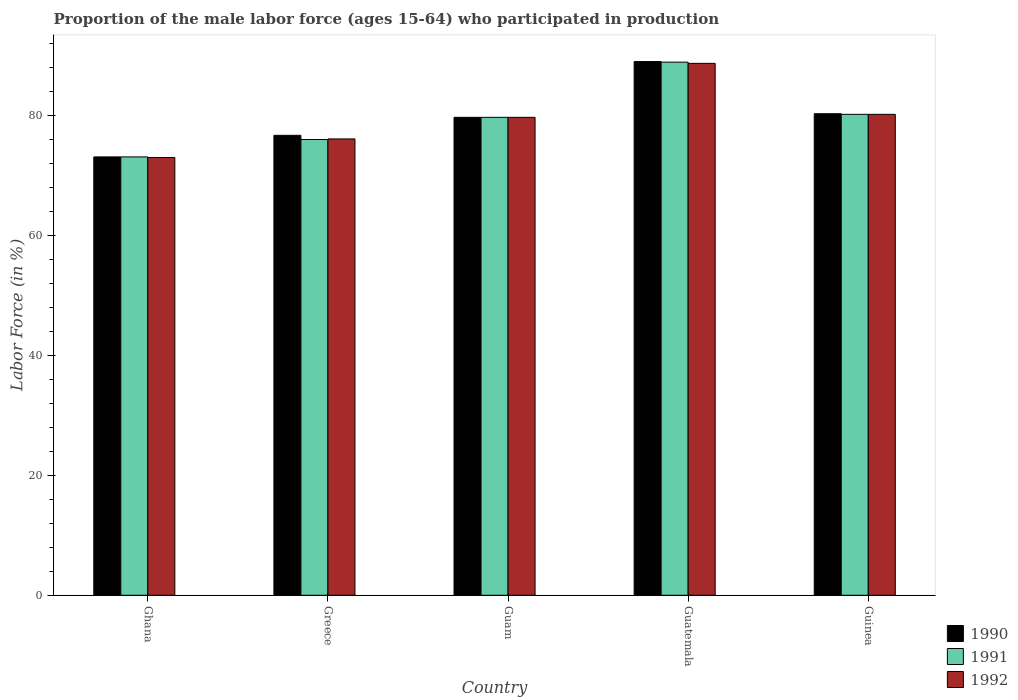How many different coloured bars are there?
Offer a very short reply. 3. How many groups of bars are there?
Keep it short and to the point. 5. Are the number of bars per tick equal to the number of legend labels?
Keep it short and to the point. Yes. How many bars are there on the 2nd tick from the left?
Your answer should be compact. 3. What is the label of the 5th group of bars from the left?
Your answer should be very brief. Guinea. In how many cases, is the number of bars for a given country not equal to the number of legend labels?
Your answer should be very brief. 0. What is the proportion of the male labor force who participated in production in 1991 in Guatemala?
Offer a very short reply. 88.9. Across all countries, what is the maximum proportion of the male labor force who participated in production in 1990?
Your response must be concise. 89. In which country was the proportion of the male labor force who participated in production in 1990 maximum?
Your response must be concise. Guatemala. In which country was the proportion of the male labor force who participated in production in 1992 minimum?
Provide a short and direct response. Ghana. What is the total proportion of the male labor force who participated in production in 1991 in the graph?
Offer a very short reply. 397.9. What is the difference between the proportion of the male labor force who participated in production in 1991 in Guatemala and that in Guinea?
Offer a very short reply. 8.7. What is the difference between the proportion of the male labor force who participated in production in 1990 in Ghana and the proportion of the male labor force who participated in production in 1991 in Guinea?
Offer a very short reply. -7.1. What is the average proportion of the male labor force who participated in production in 1992 per country?
Offer a very short reply. 79.54. What is the difference between the proportion of the male labor force who participated in production of/in 1991 and proportion of the male labor force who participated in production of/in 1990 in Greece?
Your answer should be compact. -0.7. In how many countries, is the proportion of the male labor force who participated in production in 1990 greater than 88 %?
Make the answer very short. 1. What is the ratio of the proportion of the male labor force who participated in production in 1991 in Ghana to that in Guinea?
Keep it short and to the point. 0.91. Is the proportion of the male labor force who participated in production in 1990 in Guam less than that in Guinea?
Your answer should be very brief. Yes. Is the difference between the proportion of the male labor force who participated in production in 1991 in Guam and Guinea greater than the difference between the proportion of the male labor force who participated in production in 1990 in Guam and Guinea?
Offer a terse response. Yes. What is the difference between the highest and the second highest proportion of the male labor force who participated in production in 1990?
Your response must be concise. -8.7. What is the difference between the highest and the lowest proportion of the male labor force who participated in production in 1991?
Keep it short and to the point. 15.8. What does the 2nd bar from the right in Guatemala represents?
Provide a succinct answer. 1991. How many bars are there?
Offer a very short reply. 15. Are all the bars in the graph horizontal?
Offer a terse response. No. What is the difference between two consecutive major ticks on the Y-axis?
Your answer should be compact. 20. Does the graph contain any zero values?
Make the answer very short. No. Where does the legend appear in the graph?
Your answer should be compact. Bottom right. What is the title of the graph?
Your answer should be very brief. Proportion of the male labor force (ages 15-64) who participated in production. Does "1972" appear as one of the legend labels in the graph?
Provide a succinct answer. No. What is the label or title of the X-axis?
Make the answer very short. Country. What is the Labor Force (in %) of 1990 in Ghana?
Provide a short and direct response. 73.1. What is the Labor Force (in %) in 1991 in Ghana?
Your response must be concise. 73.1. What is the Labor Force (in %) of 1990 in Greece?
Your response must be concise. 76.7. What is the Labor Force (in %) in 1991 in Greece?
Your answer should be compact. 76. What is the Labor Force (in %) of 1992 in Greece?
Your answer should be very brief. 76.1. What is the Labor Force (in %) in 1990 in Guam?
Your answer should be compact. 79.7. What is the Labor Force (in %) in 1991 in Guam?
Provide a succinct answer. 79.7. What is the Labor Force (in %) in 1992 in Guam?
Provide a succinct answer. 79.7. What is the Labor Force (in %) of 1990 in Guatemala?
Make the answer very short. 89. What is the Labor Force (in %) in 1991 in Guatemala?
Make the answer very short. 88.9. What is the Labor Force (in %) in 1992 in Guatemala?
Provide a short and direct response. 88.7. What is the Labor Force (in %) of 1990 in Guinea?
Keep it short and to the point. 80.3. What is the Labor Force (in %) in 1991 in Guinea?
Offer a very short reply. 80.2. What is the Labor Force (in %) in 1992 in Guinea?
Offer a very short reply. 80.2. Across all countries, what is the maximum Labor Force (in %) in 1990?
Give a very brief answer. 89. Across all countries, what is the maximum Labor Force (in %) of 1991?
Provide a succinct answer. 88.9. Across all countries, what is the maximum Labor Force (in %) in 1992?
Keep it short and to the point. 88.7. Across all countries, what is the minimum Labor Force (in %) of 1990?
Make the answer very short. 73.1. Across all countries, what is the minimum Labor Force (in %) of 1991?
Provide a succinct answer. 73.1. Across all countries, what is the minimum Labor Force (in %) of 1992?
Offer a very short reply. 73. What is the total Labor Force (in %) of 1990 in the graph?
Offer a terse response. 398.8. What is the total Labor Force (in %) in 1991 in the graph?
Offer a terse response. 397.9. What is the total Labor Force (in %) of 1992 in the graph?
Your answer should be very brief. 397.7. What is the difference between the Labor Force (in %) of 1990 in Ghana and that in Greece?
Provide a succinct answer. -3.6. What is the difference between the Labor Force (in %) of 1991 in Ghana and that in Guam?
Make the answer very short. -6.6. What is the difference between the Labor Force (in %) of 1990 in Ghana and that in Guatemala?
Provide a succinct answer. -15.9. What is the difference between the Labor Force (in %) in 1991 in Ghana and that in Guatemala?
Make the answer very short. -15.8. What is the difference between the Labor Force (in %) in 1992 in Ghana and that in Guatemala?
Provide a short and direct response. -15.7. What is the difference between the Labor Force (in %) in 1990 in Ghana and that in Guinea?
Your response must be concise. -7.2. What is the difference between the Labor Force (in %) of 1991 in Ghana and that in Guinea?
Offer a very short reply. -7.1. What is the difference between the Labor Force (in %) in 1990 in Greece and that in Guam?
Provide a short and direct response. -3. What is the difference between the Labor Force (in %) in 1991 in Greece and that in Guam?
Ensure brevity in your answer.  -3.7. What is the difference between the Labor Force (in %) of 1991 in Greece and that in Guatemala?
Ensure brevity in your answer.  -12.9. What is the difference between the Labor Force (in %) in 1992 in Greece and that in Guatemala?
Your answer should be compact. -12.6. What is the difference between the Labor Force (in %) in 1990 in Greece and that in Guinea?
Ensure brevity in your answer.  -3.6. What is the difference between the Labor Force (in %) of 1992 in Greece and that in Guinea?
Offer a very short reply. -4.1. What is the difference between the Labor Force (in %) in 1991 in Guam and that in Guatemala?
Ensure brevity in your answer.  -9.2. What is the difference between the Labor Force (in %) of 1992 in Guam and that in Guatemala?
Keep it short and to the point. -9. What is the difference between the Labor Force (in %) of 1991 in Guam and that in Guinea?
Keep it short and to the point. -0.5. What is the difference between the Labor Force (in %) in 1992 in Guam and that in Guinea?
Offer a terse response. -0.5. What is the difference between the Labor Force (in %) of 1990 in Guatemala and that in Guinea?
Provide a succinct answer. 8.7. What is the difference between the Labor Force (in %) in 1990 in Ghana and the Labor Force (in %) in 1992 in Guam?
Ensure brevity in your answer.  -6.6. What is the difference between the Labor Force (in %) in 1990 in Ghana and the Labor Force (in %) in 1991 in Guatemala?
Provide a short and direct response. -15.8. What is the difference between the Labor Force (in %) of 1990 in Ghana and the Labor Force (in %) of 1992 in Guatemala?
Make the answer very short. -15.6. What is the difference between the Labor Force (in %) in 1991 in Ghana and the Labor Force (in %) in 1992 in Guatemala?
Your answer should be compact. -15.6. What is the difference between the Labor Force (in %) of 1990 in Ghana and the Labor Force (in %) of 1991 in Guinea?
Offer a very short reply. -7.1. What is the difference between the Labor Force (in %) of 1990 in Ghana and the Labor Force (in %) of 1992 in Guinea?
Keep it short and to the point. -7.1. What is the difference between the Labor Force (in %) in 1991 in Ghana and the Labor Force (in %) in 1992 in Guinea?
Provide a succinct answer. -7.1. What is the difference between the Labor Force (in %) in 1990 in Greece and the Labor Force (in %) in 1991 in Guam?
Your response must be concise. -3. What is the difference between the Labor Force (in %) in 1990 in Greece and the Labor Force (in %) in 1992 in Guam?
Ensure brevity in your answer.  -3. What is the difference between the Labor Force (in %) in 1991 in Greece and the Labor Force (in %) in 1992 in Guam?
Ensure brevity in your answer.  -3.7. What is the difference between the Labor Force (in %) in 1991 in Greece and the Labor Force (in %) in 1992 in Guatemala?
Offer a terse response. -12.7. What is the difference between the Labor Force (in %) of 1990 in Greece and the Labor Force (in %) of 1991 in Guinea?
Make the answer very short. -3.5. What is the difference between the Labor Force (in %) in 1991 in Greece and the Labor Force (in %) in 1992 in Guinea?
Your answer should be compact. -4.2. What is the difference between the Labor Force (in %) in 1990 in Guam and the Labor Force (in %) in 1991 in Guatemala?
Provide a short and direct response. -9.2. What is the difference between the Labor Force (in %) in 1990 in Guam and the Labor Force (in %) in 1992 in Guatemala?
Ensure brevity in your answer.  -9. What is the difference between the Labor Force (in %) of 1990 in Guam and the Labor Force (in %) of 1992 in Guinea?
Give a very brief answer. -0.5. What is the difference between the Labor Force (in %) of 1991 in Guam and the Labor Force (in %) of 1992 in Guinea?
Keep it short and to the point. -0.5. What is the difference between the Labor Force (in %) of 1990 in Guatemala and the Labor Force (in %) of 1991 in Guinea?
Offer a very short reply. 8.8. What is the average Labor Force (in %) in 1990 per country?
Your answer should be very brief. 79.76. What is the average Labor Force (in %) in 1991 per country?
Offer a terse response. 79.58. What is the average Labor Force (in %) in 1992 per country?
Keep it short and to the point. 79.54. What is the difference between the Labor Force (in %) of 1990 and Labor Force (in %) of 1992 in Ghana?
Give a very brief answer. 0.1. What is the difference between the Labor Force (in %) of 1991 and Labor Force (in %) of 1992 in Ghana?
Make the answer very short. 0.1. What is the difference between the Labor Force (in %) in 1990 and Labor Force (in %) in 1992 in Guam?
Your answer should be very brief. 0. What is the difference between the Labor Force (in %) of 1990 and Labor Force (in %) of 1991 in Guatemala?
Ensure brevity in your answer.  0.1. What is the difference between the Labor Force (in %) of 1990 and Labor Force (in %) of 1992 in Guatemala?
Offer a very short reply. 0.3. What is the difference between the Labor Force (in %) of 1991 and Labor Force (in %) of 1992 in Guatemala?
Offer a very short reply. 0.2. What is the difference between the Labor Force (in %) of 1990 and Labor Force (in %) of 1991 in Guinea?
Provide a succinct answer. 0.1. What is the difference between the Labor Force (in %) in 1991 and Labor Force (in %) in 1992 in Guinea?
Your response must be concise. 0. What is the ratio of the Labor Force (in %) of 1990 in Ghana to that in Greece?
Ensure brevity in your answer.  0.95. What is the ratio of the Labor Force (in %) in 1991 in Ghana to that in Greece?
Your answer should be compact. 0.96. What is the ratio of the Labor Force (in %) of 1992 in Ghana to that in Greece?
Give a very brief answer. 0.96. What is the ratio of the Labor Force (in %) in 1990 in Ghana to that in Guam?
Your answer should be compact. 0.92. What is the ratio of the Labor Force (in %) in 1991 in Ghana to that in Guam?
Your response must be concise. 0.92. What is the ratio of the Labor Force (in %) in 1992 in Ghana to that in Guam?
Offer a very short reply. 0.92. What is the ratio of the Labor Force (in %) of 1990 in Ghana to that in Guatemala?
Provide a succinct answer. 0.82. What is the ratio of the Labor Force (in %) in 1991 in Ghana to that in Guatemala?
Keep it short and to the point. 0.82. What is the ratio of the Labor Force (in %) in 1992 in Ghana to that in Guatemala?
Make the answer very short. 0.82. What is the ratio of the Labor Force (in %) in 1990 in Ghana to that in Guinea?
Your response must be concise. 0.91. What is the ratio of the Labor Force (in %) of 1991 in Ghana to that in Guinea?
Provide a succinct answer. 0.91. What is the ratio of the Labor Force (in %) in 1992 in Ghana to that in Guinea?
Your response must be concise. 0.91. What is the ratio of the Labor Force (in %) in 1990 in Greece to that in Guam?
Your answer should be very brief. 0.96. What is the ratio of the Labor Force (in %) of 1991 in Greece to that in Guam?
Offer a terse response. 0.95. What is the ratio of the Labor Force (in %) of 1992 in Greece to that in Guam?
Ensure brevity in your answer.  0.95. What is the ratio of the Labor Force (in %) of 1990 in Greece to that in Guatemala?
Your answer should be compact. 0.86. What is the ratio of the Labor Force (in %) in 1991 in Greece to that in Guatemala?
Ensure brevity in your answer.  0.85. What is the ratio of the Labor Force (in %) of 1992 in Greece to that in Guatemala?
Ensure brevity in your answer.  0.86. What is the ratio of the Labor Force (in %) of 1990 in Greece to that in Guinea?
Your answer should be very brief. 0.96. What is the ratio of the Labor Force (in %) of 1991 in Greece to that in Guinea?
Keep it short and to the point. 0.95. What is the ratio of the Labor Force (in %) of 1992 in Greece to that in Guinea?
Give a very brief answer. 0.95. What is the ratio of the Labor Force (in %) of 1990 in Guam to that in Guatemala?
Your response must be concise. 0.9. What is the ratio of the Labor Force (in %) in 1991 in Guam to that in Guatemala?
Give a very brief answer. 0.9. What is the ratio of the Labor Force (in %) of 1992 in Guam to that in Guatemala?
Your response must be concise. 0.9. What is the ratio of the Labor Force (in %) of 1990 in Guatemala to that in Guinea?
Give a very brief answer. 1.11. What is the ratio of the Labor Force (in %) of 1991 in Guatemala to that in Guinea?
Your response must be concise. 1.11. What is the ratio of the Labor Force (in %) in 1992 in Guatemala to that in Guinea?
Make the answer very short. 1.11. What is the difference between the highest and the second highest Labor Force (in %) of 1990?
Your response must be concise. 8.7. What is the difference between the highest and the second highest Labor Force (in %) of 1991?
Ensure brevity in your answer.  8.7. 